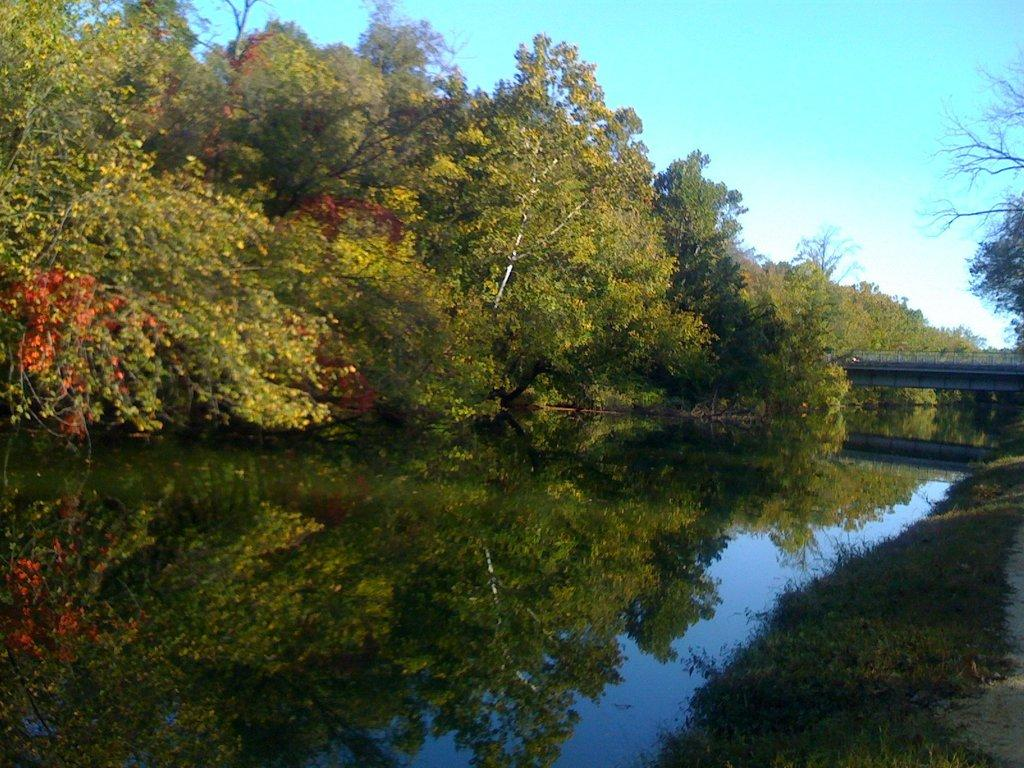What is present at the bottom of the image? There is water at the bottom of the image. What can be seen in the background of the image? There are trees in the background of the image. What is visible at the top of the image? The sky is visible at the top of the image. Where is the hook located in the image? There is no hook present in the image. What type of exchange is taking place in the lunchroom in the image? There is no lunchroom or exchange present in the image. 